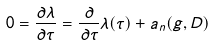<formula> <loc_0><loc_0><loc_500><loc_500>0 = \frac { \partial \lambda } { \partial \tau } = \frac { \partial } { \partial \tau } \lambda ( \tau ) + a _ { n } ( g , D )</formula> 